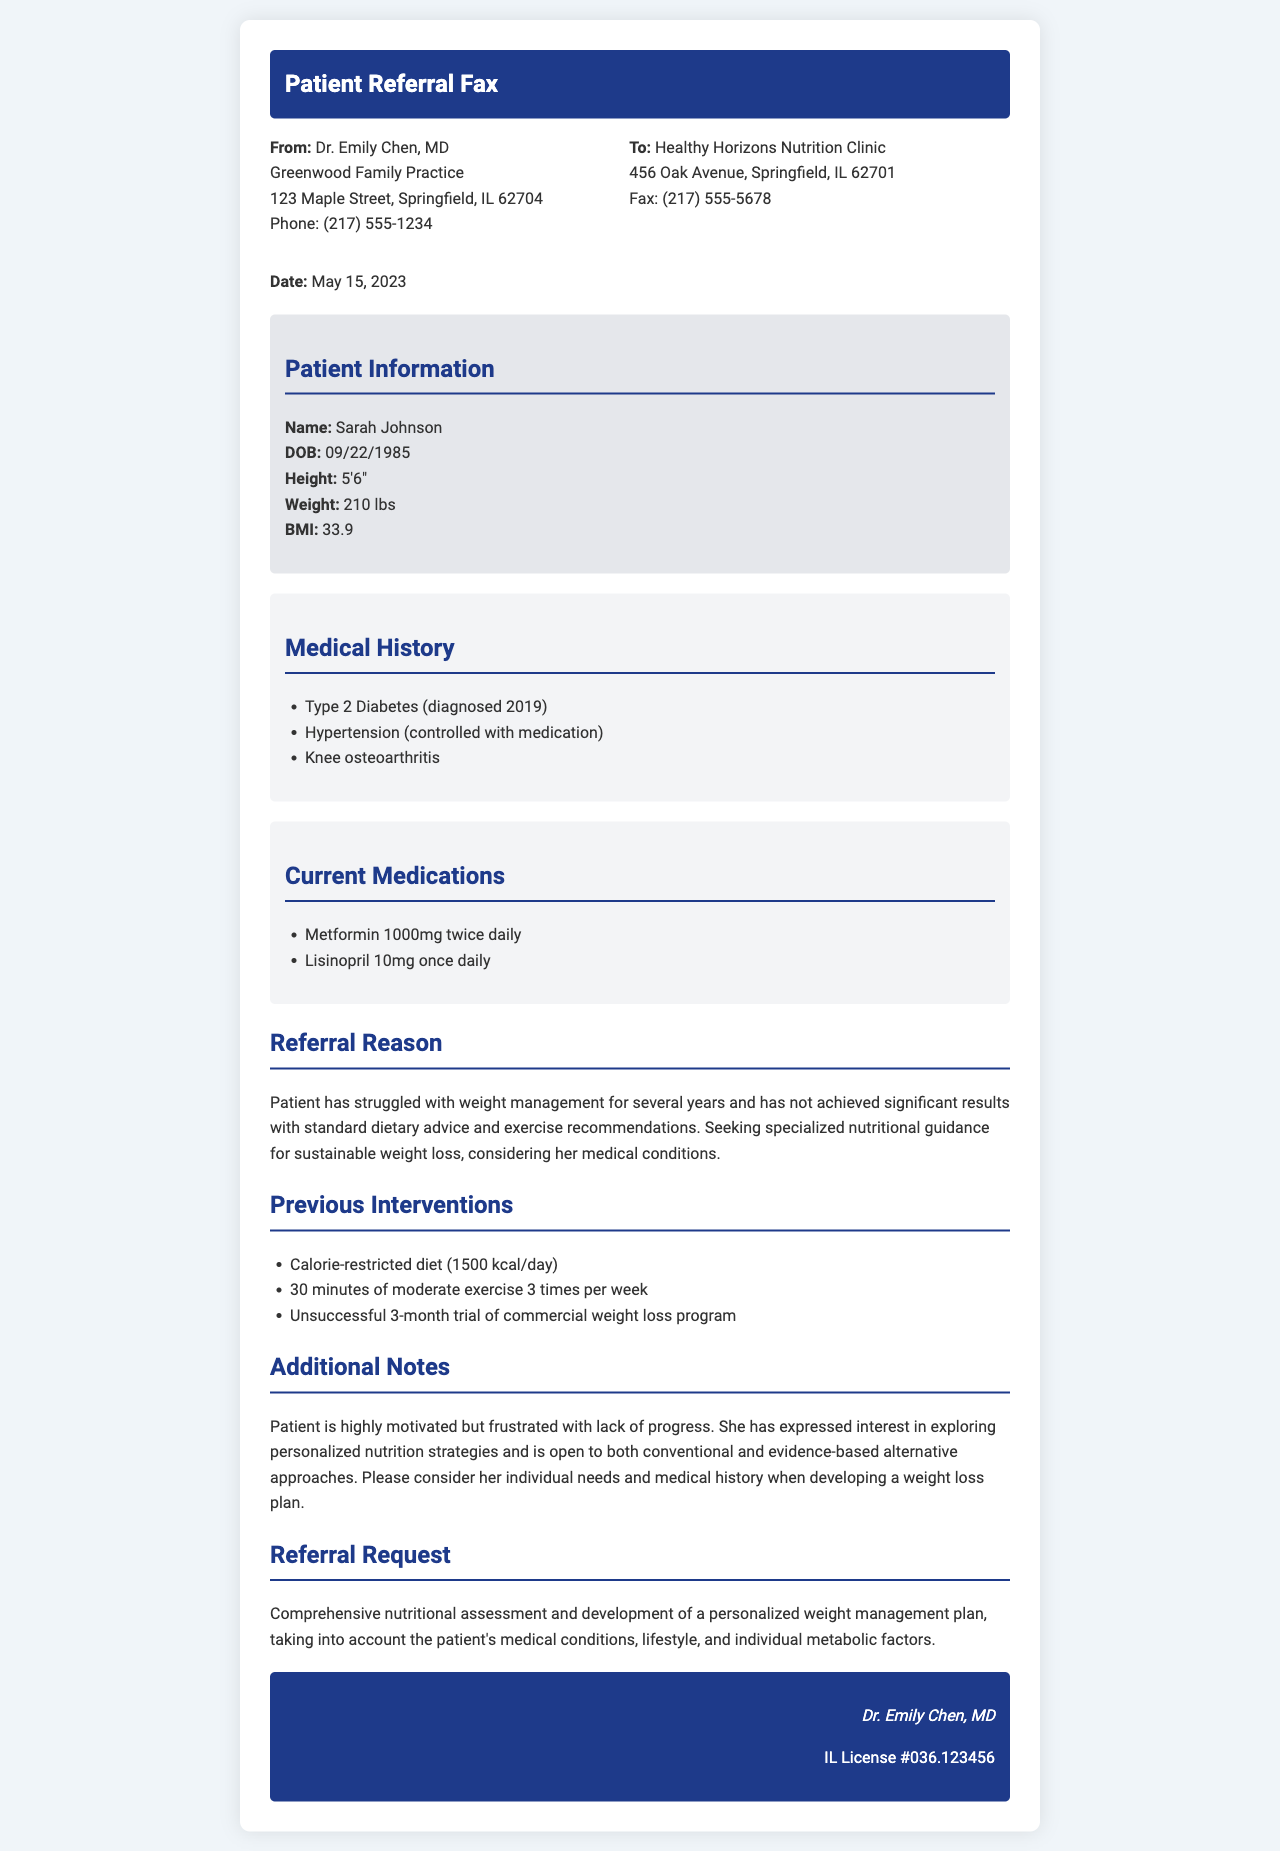What is the patient's name? The patient's name is listed in the patient information section of the document.
Answer: Sarah Johnson What is the patient's BMI? The BMI is provided in the patient information section and is calculated based on height and weight.
Answer: 33.9 What current medications is the patient taking? The current medications are listed in the medications section, which details the patient's treatment.
Answer: Metformin 1000mg twice daily, Lisinopril 10mg once daily What is the referral date? The date of the fax corresponds to the top of the document under the date section.
Answer: May 15, 2023 What are the medical conditions listed in the medical history? The medical history section includes specific conditions that affect the patient.
Answer: Type 2 Diabetes, Hypertension, Knee osteoarthritis What was the previous weight loss intervention about calorie restriction? The previous interventions describe attempts at weight management, including calorie intake.
Answer: 1500 kcal/day What is the reason for the referral? The reason is outlined in the referral reason section, summarizing the patient's struggles.
Answer: Specialized nutritional guidance for sustainable weight loss What does the patient express interest in? The additional notes section provides insight into the patient's preferences.
Answer: Exploring personalized nutrition strategies What type of assessment is being requested? The referral request section specifies the type of nutritional assessment needed for the patient.
Answer: Comprehensive nutritional assessment 